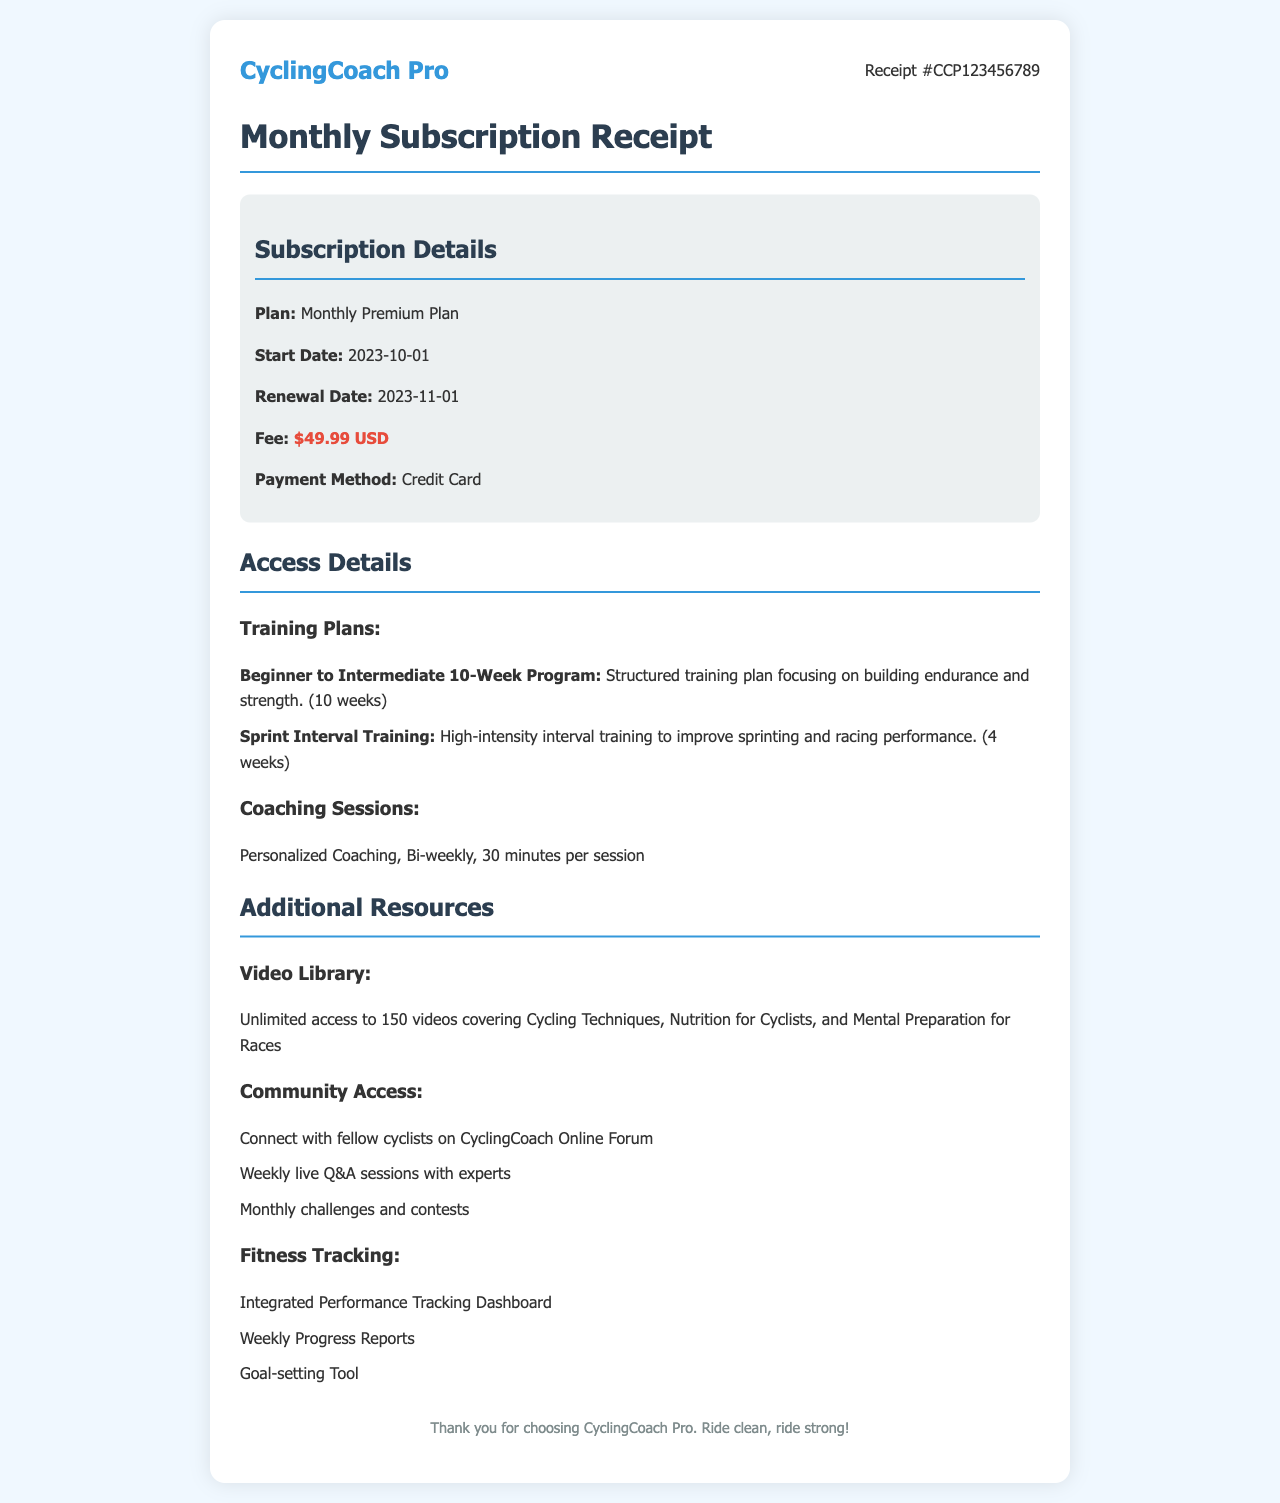What is the subscription fee? The subscription fee is listed in the document as the fee for the Monthly Premium Plan.
Answer: $49.99 USD What is the start date of the subscription? The document specifies the start date of the subscription in the subscription details section.
Answer: 2023-10-01 How many coaching sessions are included? The document mentions the frequency of the coaching sessions in the access details section.
Answer: Bi-weekly What is one type of training plan available? The access details section lists different training plans available to subscribers.
Answer: Beginner to Intermediate 10-Week Program How many videos are available in the video library? The document states the total number of videos accessible to subscribers in the additional resources section.
Answer: 150 videos What is the renewal date of the subscription? The renewal date is mentioned in the subscription details section of the document.
Answer: 2023-11-01 What tool is offered for goal-setting? The additional resources section lists several tools available, including the goal-setting tool.
Answer: Goal-setting Tool What community event occurs weekly? The additional resources section describes activities available to community members, including a specific weekly event.
Answer: Weekly live Q&A sessions What is emphasized at the end of the receipt? The footer of the document contains a concluding statement that underscores the values of the platform.
Answer: Ride clean, ride strong! 